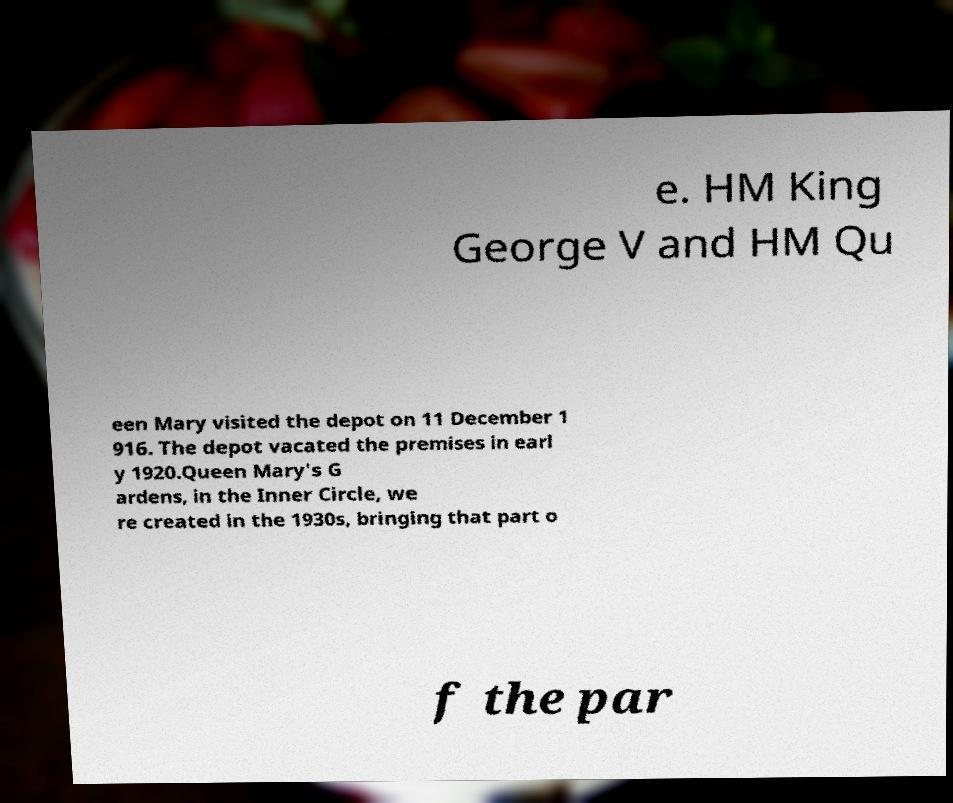For documentation purposes, I need the text within this image transcribed. Could you provide that? e. HM King George V and HM Qu een Mary visited the depot on 11 December 1 916. The depot vacated the premises in earl y 1920.Queen Mary's G ardens, in the Inner Circle, we re created in the 1930s, bringing that part o f the par 